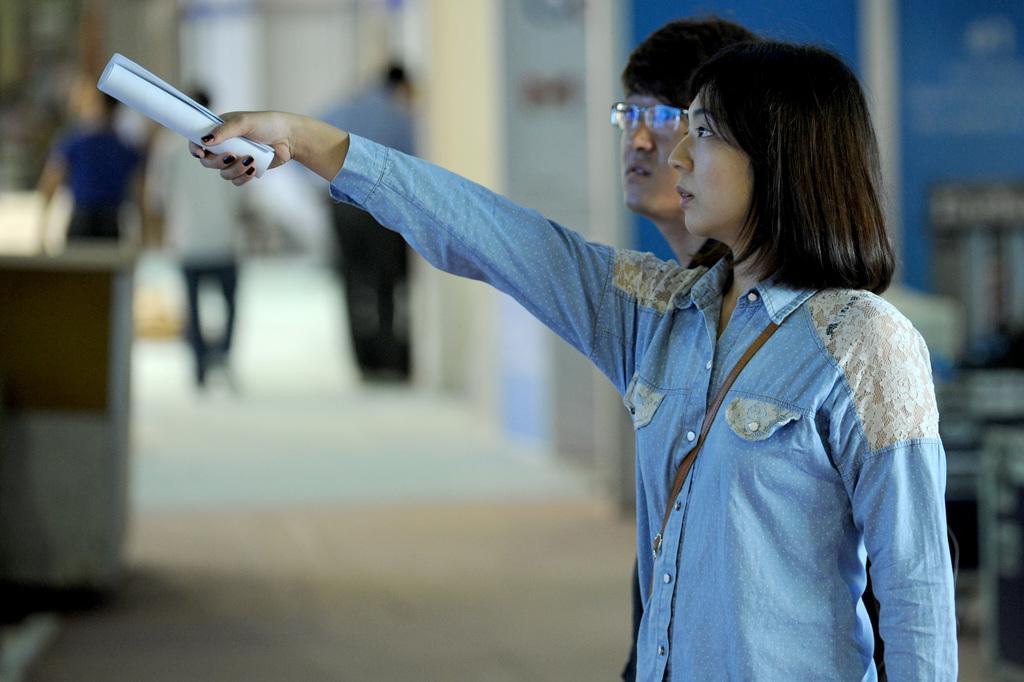How would you summarize this image in a sentence or two? In this image, there are a few people. Among them, a person is holding an object. We can see the ground. We can also see the blurred background. 